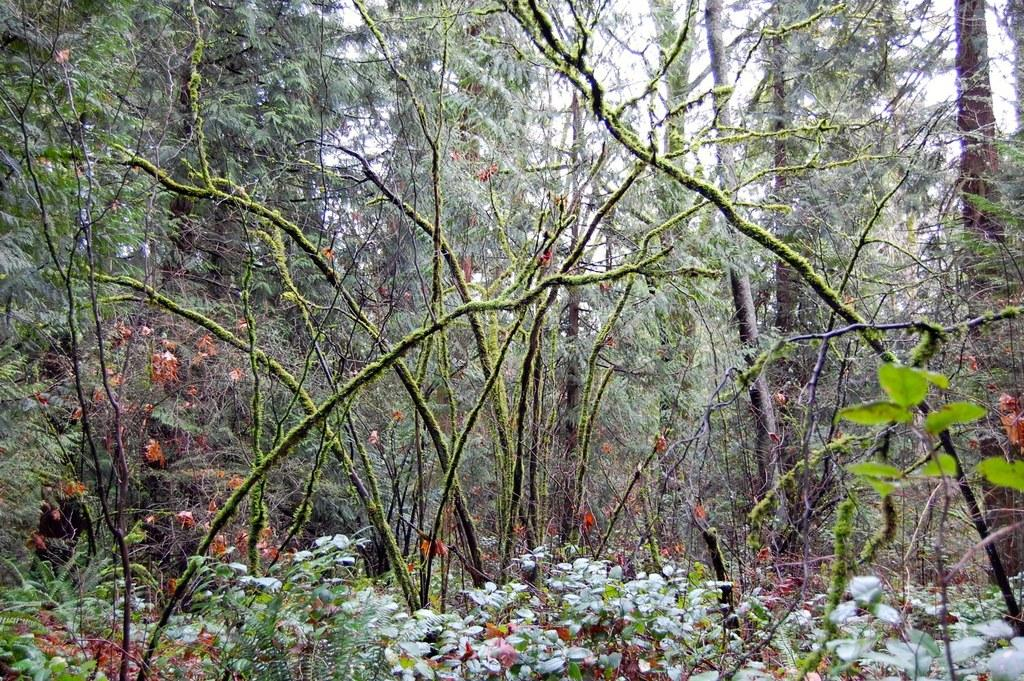What type of vegetation is visible in the image? There are trees and plants visible in the image. Can you describe the setting where the trees and plants are located? The setting is not specified, but the presence of trees and plants suggests a natural environment. How many rays can be seen swimming in the ocean in the image? There is no ocean or rays present in the image; it features trees and plants. What type of country is depicted in the image? The image does not depict a country; it features trees and plants in an unspecified setting. 